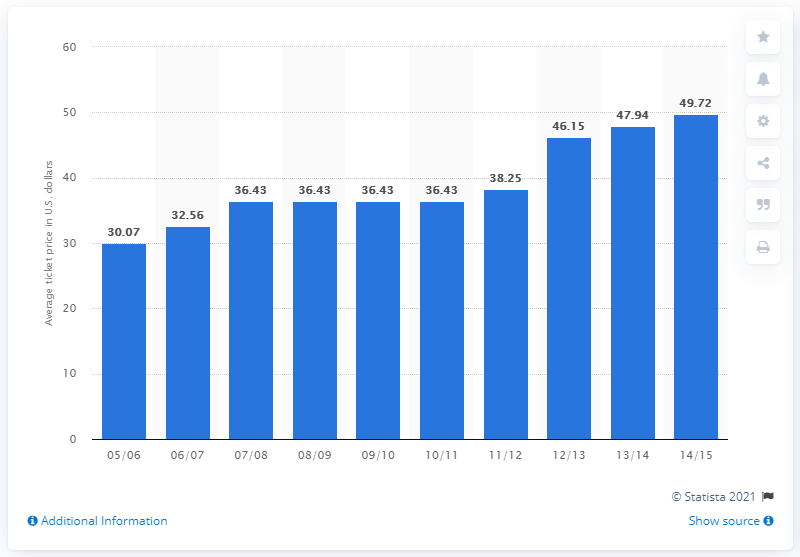Give some essential details in this illustration. In the 2005/06 season, the average ticket price was approximately $30.07. 